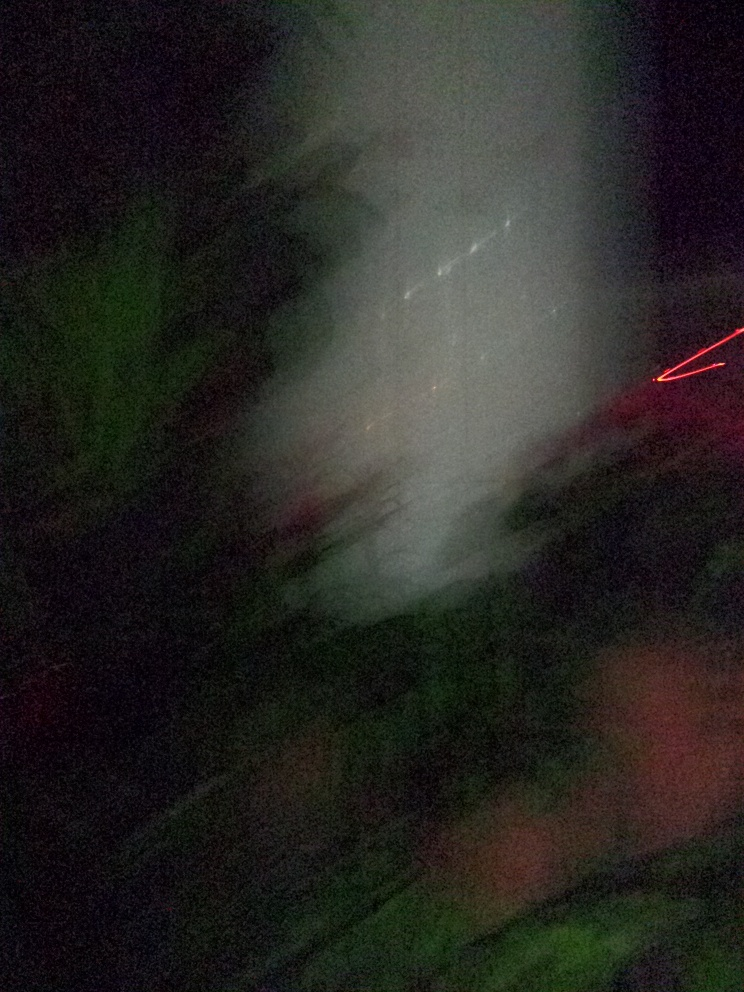What mood does this image evoke? The image has an ethereal and mysterious mood, evoking feelings of curiosity and confusion due to its lack of clear subjects and its blur. The dark tones and vague shapes might also suggest a sense of unease or disorientation, while the streaks of light could add a dynamic or even chaotic element to the overall atmosphere of the photograph. 